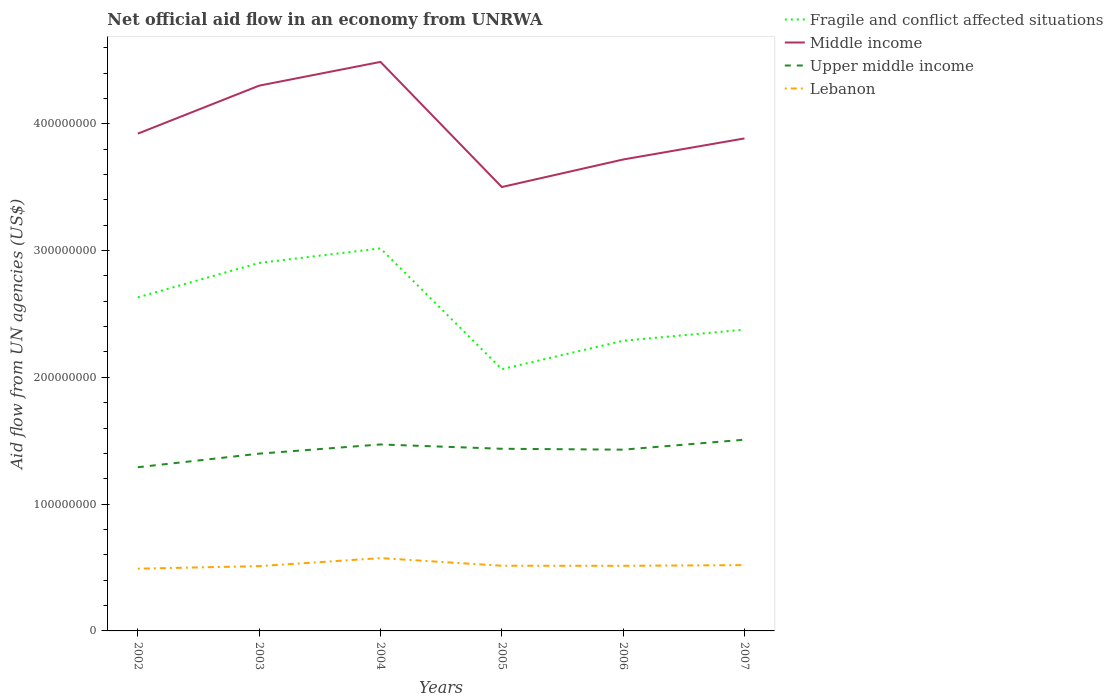Does the line corresponding to Middle income intersect with the line corresponding to Lebanon?
Your response must be concise. No. Across all years, what is the maximum net official aid flow in Fragile and conflict affected situations?
Make the answer very short. 2.06e+08. What is the total net official aid flow in Lebanon in the graph?
Ensure brevity in your answer.  -2.02e+06. What is the difference between the highest and the second highest net official aid flow in Upper middle income?
Your answer should be compact. 2.17e+07. What is the difference between the highest and the lowest net official aid flow in Fragile and conflict affected situations?
Provide a short and direct response. 3. How many lines are there?
Offer a terse response. 4. How many years are there in the graph?
Your answer should be very brief. 6. Are the values on the major ticks of Y-axis written in scientific E-notation?
Make the answer very short. No. How many legend labels are there?
Your response must be concise. 4. How are the legend labels stacked?
Ensure brevity in your answer.  Vertical. What is the title of the graph?
Give a very brief answer. Net official aid flow in an economy from UNRWA. What is the label or title of the X-axis?
Make the answer very short. Years. What is the label or title of the Y-axis?
Offer a terse response. Aid flow from UN agencies (US$). What is the Aid flow from UN agencies (US$) in Fragile and conflict affected situations in 2002?
Keep it short and to the point. 2.63e+08. What is the Aid flow from UN agencies (US$) in Middle income in 2002?
Ensure brevity in your answer.  3.92e+08. What is the Aid flow from UN agencies (US$) of Upper middle income in 2002?
Give a very brief answer. 1.29e+08. What is the Aid flow from UN agencies (US$) in Lebanon in 2002?
Offer a very short reply. 4.91e+07. What is the Aid flow from UN agencies (US$) of Fragile and conflict affected situations in 2003?
Your response must be concise. 2.90e+08. What is the Aid flow from UN agencies (US$) of Middle income in 2003?
Offer a very short reply. 4.30e+08. What is the Aid flow from UN agencies (US$) in Upper middle income in 2003?
Offer a terse response. 1.40e+08. What is the Aid flow from UN agencies (US$) of Lebanon in 2003?
Offer a terse response. 5.11e+07. What is the Aid flow from UN agencies (US$) in Fragile and conflict affected situations in 2004?
Your answer should be very brief. 3.02e+08. What is the Aid flow from UN agencies (US$) in Middle income in 2004?
Make the answer very short. 4.49e+08. What is the Aid flow from UN agencies (US$) of Upper middle income in 2004?
Give a very brief answer. 1.47e+08. What is the Aid flow from UN agencies (US$) of Lebanon in 2004?
Your response must be concise. 5.74e+07. What is the Aid flow from UN agencies (US$) of Fragile and conflict affected situations in 2005?
Provide a short and direct response. 2.06e+08. What is the Aid flow from UN agencies (US$) of Middle income in 2005?
Ensure brevity in your answer.  3.50e+08. What is the Aid flow from UN agencies (US$) of Upper middle income in 2005?
Offer a very short reply. 1.44e+08. What is the Aid flow from UN agencies (US$) of Lebanon in 2005?
Your answer should be compact. 5.14e+07. What is the Aid flow from UN agencies (US$) of Fragile and conflict affected situations in 2006?
Make the answer very short. 2.29e+08. What is the Aid flow from UN agencies (US$) in Middle income in 2006?
Your answer should be compact. 3.72e+08. What is the Aid flow from UN agencies (US$) in Upper middle income in 2006?
Give a very brief answer. 1.43e+08. What is the Aid flow from UN agencies (US$) in Lebanon in 2006?
Give a very brief answer. 5.14e+07. What is the Aid flow from UN agencies (US$) of Fragile and conflict affected situations in 2007?
Keep it short and to the point. 2.38e+08. What is the Aid flow from UN agencies (US$) of Middle income in 2007?
Provide a short and direct response. 3.88e+08. What is the Aid flow from UN agencies (US$) of Upper middle income in 2007?
Give a very brief answer. 1.51e+08. What is the Aid flow from UN agencies (US$) in Lebanon in 2007?
Give a very brief answer. 5.19e+07. Across all years, what is the maximum Aid flow from UN agencies (US$) of Fragile and conflict affected situations?
Give a very brief answer. 3.02e+08. Across all years, what is the maximum Aid flow from UN agencies (US$) of Middle income?
Make the answer very short. 4.49e+08. Across all years, what is the maximum Aid flow from UN agencies (US$) in Upper middle income?
Ensure brevity in your answer.  1.51e+08. Across all years, what is the maximum Aid flow from UN agencies (US$) in Lebanon?
Provide a short and direct response. 5.74e+07. Across all years, what is the minimum Aid flow from UN agencies (US$) in Fragile and conflict affected situations?
Offer a terse response. 2.06e+08. Across all years, what is the minimum Aid flow from UN agencies (US$) of Middle income?
Your answer should be very brief. 3.50e+08. Across all years, what is the minimum Aid flow from UN agencies (US$) of Upper middle income?
Provide a succinct answer. 1.29e+08. Across all years, what is the minimum Aid flow from UN agencies (US$) of Lebanon?
Provide a short and direct response. 4.91e+07. What is the total Aid flow from UN agencies (US$) of Fragile and conflict affected situations in the graph?
Your answer should be compact. 1.53e+09. What is the total Aid flow from UN agencies (US$) in Middle income in the graph?
Ensure brevity in your answer.  2.38e+09. What is the total Aid flow from UN agencies (US$) of Upper middle income in the graph?
Give a very brief answer. 8.53e+08. What is the total Aid flow from UN agencies (US$) in Lebanon in the graph?
Your response must be concise. 3.12e+08. What is the difference between the Aid flow from UN agencies (US$) in Fragile and conflict affected situations in 2002 and that in 2003?
Offer a very short reply. -2.72e+07. What is the difference between the Aid flow from UN agencies (US$) in Middle income in 2002 and that in 2003?
Ensure brevity in your answer.  -3.79e+07. What is the difference between the Aid flow from UN agencies (US$) in Upper middle income in 2002 and that in 2003?
Offer a terse response. -1.07e+07. What is the difference between the Aid flow from UN agencies (US$) in Lebanon in 2002 and that in 2003?
Offer a very short reply. -2.02e+06. What is the difference between the Aid flow from UN agencies (US$) in Fragile and conflict affected situations in 2002 and that in 2004?
Ensure brevity in your answer.  -3.86e+07. What is the difference between the Aid flow from UN agencies (US$) in Middle income in 2002 and that in 2004?
Keep it short and to the point. -5.66e+07. What is the difference between the Aid flow from UN agencies (US$) of Upper middle income in 2002 and that in 2004?
Give a very brief answer. -1.80e+07. What is the difference between the Aid flow from UN agencies (US$) in Lebanon in 2002 and that in 2004?
Provide a short and direct response. -8.34e+06. What is the difference between the Aid flow from UN agencies (US$) in Fragile and conflict affected situations in 2002 and that in 2005?
Offer a terse response. 5.67e+07. What is the difference between the Aid flow from UN agencies (US$) in Middle income in 2002 and that in 2005?
Provide a short and direct response. 4.21e+07. What is the difference between the Aid flow from UN agencies (US$) in Upper middle income in 2002 and that in 2005?
Your answer should be compact. -1.46e+07. What is the difference between the Aid flow from UN agencies (US$) in Lebanon in 2002 and that in 2005?
Ensure brevity in your answer.  -2.33e+06. What is the difference between the Aid flow from UN agencies (US$) in Fragile and conflict affected situations in 2002 and that in 2006?
Your response must be concise. 3.42e+07. What is the difference between the Aid flow from UN agencies (US$) of Middle income in 2002 and that in 2006?
Your response must be concise. 2.04e+07. What is the difference between the Aid flow from UN agencies (US$) in Upper middle income in 2002 and that in 2006?
Make the answer very short. -1.39e+07. What is the difference between the Aid flow from UN agencies (US$) of Lebanon in 2002 and that in 2006?
Keep it short and to the point. -2.27e+06. What is the difference between the Aid flow from UN agencies (US$) of Fragile and conflict affected situations in 2002 and that in 2007?
Your answer should be compact. 2.55e+07. What is the difference between the Aid flow from UN agencies (US$) of Middle income in 2002 and that in 2007?
Provide a succinct answer. 3.76e+06. What is the difference between the Aid flow from UN agencies (US$) of Upper middle income in 2002 and that in 2007?
Provide a succinct answer. -2.17e+07. What is the difference between the Aid flow from UN agencies (US$) of Lebanon in 2002 and that in 2007?
Provide a succinct answer. -2.80e+06. What is the difference between the Aid flow from UN agencies (US$) of Fragile and conflict affected situations in 2003 and that in 2004?
Give a very brief answer. -1.15e+07. What is the difference between the Aid flow from UN agencies (US$) in Middle income in 2003 and that in 2004?
Ensure brevity in your answer.  -1.87e+07. What is the difference between the Aid flow from UN agencies (US$) in Upper middle income in 2003 and that in 2004?
Your response must be concise. -7.26e+06. What is the difference between the Aid flow from UN agencies (US$) in Lebanon in 2003 and that in 2004?
Offer a very short reply. -6.32e+06. What is the difference between the Aid flow from UN agencies (US$) in Fragile and conflict affected situations in 2003 and that in 2005?
Offer a very short reply. 8.38e+07. What is the difference between the Aid flow from UN agencies (US$) in Middle income in 2003 and that in 2005?
Give a very brief answer. 8.00e+07. What is the difference between the Aid flow from UN agencies (US$) in Upper middle income in 2003 and that in 2005?
Ensure brevity in your answer.  -3.86e+06. What is the difference between the Aid flow from UN agencies (US$) in Lebanon in 2003 and that in 2005?
Provide a short and direct response. -3.10e+05. What is the difference between the Aid flow from UN agencies (US$) in Fragile and conflict affected situations in 2003 and that in 2006?
Provide a succinct answer. 6.14e+07. What is the difference between the Aid flow from UN agencies (US$) in Middle income in 2003 and that in 2006?
Keep it short and to the point. 5.82e+07. What is the difference between the Aid flow from UN agencies (US$) in Upper middle income in 2003 and that in 2006?
Your answer should be compact. -3.15e+06. What is the difference between the Aid flow from UN agencies (US$) in Fragile and conflict affected situations in 2003 and that in 2007?
Your answer should be compact. 5.26e+07. What is the difference between the Aid flow from UN agencies (US$) of Middle income in 2003 and that in 2007?
Keep it short and to the point. 4.16e+07. What is the difference between the Aid flow from UN agencies (US$) in Upper middle income in 2003 and that in 2007?
Make the answer very short. -1.10e+07. What is the difference between the Aid flow from UN agencies (US$) in Lebanon in 2003 and that in 2007?
Make the answer very short. -7.80e+05. What is the difference between the Aid flow from UN agencies (US$) of Fragile and conflict affected situations in 2004 and that in 2005?
Make the answer very short. 9.53e+07. What is the difference between the Aid flow from UN agencies (US$) in Middle income in 2004 and that in 2005?
Provide a succinct answer. 9.87e+07. What is the difference between the Aid flow from UN agencies (US$) of Upper middle income in 2004 and that in 2005?
Provide a succinct answer. 3.40e+06. What is the difference between the Aid flow from UN agencies (US$) in Lebanon in 2004 and that in 2005?
Your response must be concise. 6.01e+06. What is the difference between the Aid flow from UN agencies (US$) in Fragile and conflict affected situations in 2004 and that in 2006?
Offer a very short reply. 7.29e+07. What is the difference between the Aid flow from UN agencies (US$) of Middle income in 2004 and that in 2006?
Give a very brief answer. 7.70e+07. What is the difference between the Aid flow from UN agencies (US$) of Upper middle income in 2004 and that in 2006?
Give a very brief answer. 4.11e+06. What is the difference between the Aid flow from UN agencies (US$) of Lebanon in 2004 and that in 2006?
Keep it short and to the point. 6.07e+06. What is the difference between the Aid flow from UN agencies (US$) of Fragile and conflict affected situations in 2004 and that in 2007?
Keep it short and to the point. 6.41e+07. What is the difference between the Aid flow from UN agencies (US$) of Middle income in 2004 and that in 2007?
Provide a succinct answer. 6.03e+07. What is the difference between the Aid flow from UN agencies (US$) of Upper middle income in 2004 and that in 2007?
Your response must be concise. -3.75e+06. What is the difference between the Aid flow from UN agencies (US$) of Lebanon in 2004 and that in 2007?
Ensure brevity in your answer.  5.54e+06. What is the difference between the Aid flow from UN agencies (US$) in Fragile and conflict affected situations in 2005 and that in 2006?
Keep it short and to the point. -2.24e+07. What is the difference between the Aid flow from UN agencies (US$) in Middle income in 2005 and that in 2006?
Offer a very short reply. -2.17e+07. What is the difference between the Aid flow from UN agencies (US$) of Upper middle income in 2005 and that in 2006?
Your answer should be very brief. 7.10e+05. What is the difference between the Aid flow from UN agencies (US$) of Fragile and conflict affected situations in 2005 and that in 2007?
Provide a succinct answer. -3.12e+07. What is the difference between the Aid flow from UN agencies (US$) of Middle income in 2005 and that in 2007?
Offer a very short reply. -3.83e+07. What is the difference between the Aid flow from UN agencies (US$) of Upper middle income in 2005 and that in 2007?
Offer a terse response. -7.15e+06. What is the difference between the Aid flow from UN agencies (US$) in Lebanon in 2005 and that in 2007?
Your response must be concise. -4.70e+05. What is the difference between the Aid flow from UN agencies (US$) of Fragile and conflict affected situations in 2006 and that in 2007?
Offer a terse response. -8.77e+06. What is the difference between the Aid flow from UN agencies (US$) of Middle income in 2006 and that in 2007?
Your answer should be very brief. -1.66e+07. What is the difference between the Aid flow from UN agencies (US$) of Upper middle income in 2006 and that in 2007?
Provide a succinct answer. -7.86e+06. What is the difference between the Aid flow from UN agencies (US$) in Lebanon in 2006 and that in 2007?
Your answer should be compact. -5.30e+05. What is the difference between the Aid flow from UN agencies (US$) of Fragile and conflict affected situations in 2002 and the Aid flow from UN agencies (US$) of Middle income in 2003?
Give a very brief answer. -1.67e+08. What is the difference between the Aid flow from UN agencies (US$) in Fragile and conflict affected situations in 2002 and the Aid flow from UN agencies (US$) in Upper middle income in 2003?
Provide a short and direct response. 1.23e+08. What is the difference between the Aid flow from UN agencies (US$) of Fragile and conflict affected situations in 2002 and the Aid flow from UN agencies (US$) of Lebanon in 2003?
Your answer should be very brief. 2.12e+08. What is the difference between the Aid flow from UN agencies (US$) of Middle income in 2002 and the Aid flow from UN agencies (US$) of Upper middle income in 2003?
Your answer should be compact. 2.52e+08. What is the difference between the Aid flow from UN agencies (US$) of Middle income in 2002 and the Aid flow from UN agencies (US$) of Lebanon in 2003?
Ensure brevity in your answer.  3.41e+08. What is the difference between the Aid flow from UN agencies (US$) in Upper middle income in 2002 and the Aid flow from UN agencies (US$) in Lebanon in 2003?
Your answer should be compact. 7.80e+07. What is the difference between the Aid flow from UN agencies (US$) of Fragile and conflict affected situations in 2002 and the Aid flow from UN agencies (US$) of Middle income in 2004?
Offer a terse response. -1.86e+08. What is the difference between the Aid flow from UN agencies (US$) of Fragile and conflict affected situations in 2002 and the Aid flow from UN agencies (US$) of Upper middle income in 2004?
Your answer should be very brief. 1.16e+08. What is the difference between the Aid flow from UN agencies (US$) of Fragile and conflict affected situations in 2002 and the Aid flow from UN agencies (US$) of Lebanon in 2004?
Your answer should be compact. 2.06e+08. What is the difference between the Aid flow from UN agencies (US$) of Middle income in 2002 and the Aid flow from UN agencies (US$) of Upper middle income in 2004?
Keep it short and to the point. 2.45e+08. What is the difference between the Aid flow from UN agencies (US$) of Middle income in 2002 and the Aid flow from UN agencies (US$) of Lebanon in 2004?
Give a very brief answer. 3.35e+08. What is the difference between the Aid flow from UN agencies (US$) of Upper middle income in 2002 and the Aid flow from UN agencies (US$) of Lebanon in 2004?
Your answer should be compact. 7.17e+07. What is the difference between the Aid flow from UN agencies (US$) in Fragile and conflict affected situations in 2002 and the Aid flow from UN agencies (US$) in Middle income in 2005?
Give a very brief answer. -8.70e+07. What is the difference between the Aid flow from UN agencies (US$) of Fragile and conflict affected situations in 2002 and the Aid flow from UN agencies (US$) of Upper middle income in 2005?
Make the answer very short. 1.19e+08. What is the difference between the Aid flow from UN agencies (US$) in Fragile and conflict affected situations in 2002 and the Aid flow from UN agencies (US$) in Lebanon in 2005?
Ensure brevity in your answer.  2.12e+08. What is the difference between the Aid flow from UN agencies (US$) in Middle income in 2002 and the Aid flow from UN agencies (US$) in Upper middle income in 2005?
Make the answer very short. 2.49e+08. What is the difference between the Aid flow from UN agencies (US$) in Middle income in 2002 and the Aid flow from UN agencies (US$) in Lebanon in 2005?
Offer a very short reply. 3.41e+08. What is the difference between the Aid flow from UN agencies (US$) in Upper middle income in 2002 and the Aid flow from UN agencies (US$) in Lebanon in 2005?
Your answer should be compact. 7.77e+07. What is the difference between the Aid flow from UN agencies (US$) of Fragile and conflict affected situations in 2002 and the Aid flow from UN agencies (US$) of Middle income in 2006?
Your response must be concise. -1.09e+08. What is the difference between the Aid flow from UN agencies (US$) in Fragile and conflict affected situations in 2002 and the Aid flow from UN agencies (US$) in Upper middle income in 2006?
Offer a terse response. 1.20e+08. What is the difference between the Aid flow from UN agencies (US$) in Fragile and conflict affected situations in 2002 and the Aid flow from UN agencies (US$) in Lebanon in 2006?
Provide a succinct answer. 2.12e+08. What is the difference between the Aid flow from UN agencies (US$) in Middle income in 2002 and the Aid flow from UN agencies (US$) in Upper middle income in 2006?
Your response must be concise. 2.49e+08. What is the difference between the Aid flow from UN agencies (US$) in Middle income in 2002 and the Aid flow from UN agencies (US$) in Lebanon in 2006?
Make the answer very short. 3.41e+08. What is the difference between the Aid flow from UN agencies (US$) in Upper middle income in 2002 and the Aid flow from UN agencies (US$) in Lebanon in 2006?
Provide a short and direct response. 7.77e+07. What is the difference between the Aid flow from UN agencies (US$) of Fragile and conflict affected situations in 2002 and the Aid flow from UN agencies (US$) of Middle income in 2007?
Your answer should be very brief. -1.25e+08. What is the difference between the Aid flow from UN agencies (US$) of Fragile and conflict affected situations in 2002 and the Aid flow from UN agencies (US$) of Upper middle income in 2007?
Provide a short and direct response. 1.12e+08. What is the difference between the Aid flow from UN agencies (US$) in Fragile and conflict affected situations in 2002 and the Aid flow from UN agencies (US$) in Lebanon in 2007?
Your answer should be compact. 2.11e+08. What is the difference between the Aid flow from UN agencies (US$) of Middle income in 2002 and the Aid flow from UN agencies (US$) of Upper middle income in 2007?
Provide a short and direct response. 2.41e+08. What is the difference between the Aid flow from UN agencies (US$) of Middle income in 2002 and the Aid flow from UN agencies (US$) of Lebanon in 2007?
Provide a succinct answer. 3.40e+08. What is the difference between the Aid flow from UN agencies (US$) in Upper middle income in 2002 and the Aid flow from UN agencies (US$) in Lebanon in 2007?
Offer a very short reply. 7.72e+07. What is the difference between the Aid flow from UN agencies (US$) in Fragile and conflict affected situations in 2003 and the Aid flow from UN agencies (US$) in Middle income in 2004?
Offer a terse response. -1.59e+08. What is the difference between the Aid flow from UN agencies (US$) in Fragile and conflict affected situations in 2003 and the Aid flow from UN agencies (US$) in Upper middle income in 2004?
Provide a short and direct response. 1.43e+08. What is the difference between the Aid flow from UN agencies (US$) in Fragile and conflict affected situations in 2003 and the Aid flow from UN agencies (US$) in Lebanon in 2004?
Provide a succinct answer. 2.33e+08. What is the difference between the Aid flow from UN agencies (US$) of Middle income in 2003 and the Aid flow from UN agencies (US$) of Upper middle income in 2004?
Ensure brevity in your answer.  2.83e+08. What is the difference between the Aid flow from UN agencies (US$) of Middle income in 2003 and the Aid flow from UN agencies (US$) of Lebanon in 2004?
Ensure brevity in your answer.  3.73e+08. What is the difference between the Aid flow from UN agencies (US$) of Upper middle income in 2003 and the Aid flow from UN agencies (US$) of Lebanon in 2004?
Make the answer very short. 8.24e+07. What is the difference between the Aid flow from UN agencies (US$) of Fragile and conflict affected situations in 2003 and the Aid flow from UN agencies (US$) of Middle income in 2005?
Give a very brief answer. -5.99e+07. What is the difference between the Aid flow from UN agencies (US$) in Fragile and conflict affected situations in 2003 and the Aid flow from UN agencies (US$) in Upper middle income in 2005?
Keep it short and to the point. 1.47e+08. What is the difference between the Aid flow from UN agencies (US$) in Fragile and conflict affected situations in 2003 and the Aid flow from UN agencies (US$) in Lebanon in 2005?
Make the answer very short. 2.39e+08. What is the difference between the Aid flow from UN agencies (US$) of Middle income in 2003 and the Aid flow from UN agencies (US$) of Upper middle income in 2005?
Ensure brevity in your answer.  2.86e+08. What is the difference between the Aid flow from UN agencies (US$) of Middle income in 2003 and the Aid flow from UN agencies (US$) of Lebanon in 2005?
Provide a short and direct response. 3.79e+08. What is the difference between the Aid flow from UN agencies (US$) in Upper middle income in 2003 and the Aid flow from UN agencies (US$) in Lebanon in 2005?
Your answer should be compact. 8.84e+07. What is the difference between the Aid flow from UN agencies (US$) in Fragile and conflict affected situations in 2003 and the Aid flow from UN agencies (US$) in Middle income in 2006?
Give a very brief answer. -8.16e+07. What is the difference between the Aid flow from UN agencies (US$) of Fragile and conflict affected situations in 2003 and the Aid flow from UN agencies (US$) of Upper middle income in 2006?
Provide a short and direct response. 1.47e+08. What is the difference between the Aid flow from UN agencies (US$) in Fragile and conflict affected situations in 2003 and the Aid flow from UN agencies (US$) in Lebanon in 2006?
Your answer should be compact. 2.39e+08. What is the difference between the Aid flow from UN agencies (US$) in Middle income in 2003 and the Aid flow from UN agencies (US$) in Upper middle income in 2006?
Offer a very short reply. 2.87e+08. What is the difference between the Aid flow from UN agencies (US$) of Middle income in 2003 and the Aid flow from UN agencies (US$) of Lebanon in 2006?
Ensure brevity in your answer.  3.79e+08. What is the difference between the Aid flow from UN agencies (US$) in Upper middle income in 2003 and the Aid flow from UN agencies (US$) in Lebanon in 2006?
Your answer should be very brief. 8.84e+07. What is the difference between the Aid flow from UN agencies (US$) in Fragile and conflict affected situations in 2003 and the Aid flow from UN agencies (US$) in Middle income in 2007?
Give a very brief answer. -9.82e+07. What is the difference between the Aid flow from UN agencies (US$) in Fragile and conflict affected situations in 2003 and the Aid flow from UN agencies (US$) in Upper middle income in 2007?
Keep it short and to the point. 1.39e+08. What is the difference between the Aid flow from UN agencies (US$) in Fragile and conflict affected situations in 2003 and the Aid flow from UN agencies (US$) in Lebanon in 2007?
Make the answer very short. 2.38e+08. What is the difference between the Aid flow from UN agencies (US$) in Middle income in 2003 and the Aid flow from UN agencies (US$) in Upper middle income in 2007?
Your response must be concise. 2.79e+08. What is the difference between the Aid flow from UN agencies (US$) in Middle income in 2003 and the Aid flow from UN agencies (US$) in Lebanon in 2007?
Provide a succinct answer. 3.78e+08. What is the difference between the Aid flow from UN agencies (US$) of Upper middle income in 2003 and the Aid flow from UN agencies (US$) of Lebanon in 2007?
Provide a short and direct response. 8.79e+07. What is the difference between the Aid flow from UN agencies (US$) in Fragile and conflict affected situations in 2004 and the Aid flow from UN agencies (US$) in Middle income in 2005?
Keep it short and to the point. -4.84e+07. What is the difference between the Aid flow from UN agencies (US$) of Fragile and conflict affected situations in 2004 and the Aid flow from UN agencies (US$) of Upper middle income in 2005?
Your answer should be compact. 1.58e+08. What is the difference between the Aid flow from UN agencies (US$) in Fragile and conflict affected situations in 2004 and the Aid flow from UN agencies (US$) in Lebanon in 2005?
Give a very brief answer. 2.50e+08. What is the difference between the Aid flow from UN agencies (US$) of Middle income in 2004 and the Aid flow from UN agencies (US$) of Upper middle income in 2005?
Your answer should be very brief. 3.05e+08. What is the difference between the Aid flow from UN agencies (US$) of Middle income in 2004 and the Aid flow from UN agencies (US$) of Lebanon in 2005?
Your answer should be very brief. 3.97e+08. What is the difference between the Aid flow from UN agencies (US$) in Upper middle income in 2004 and the Aid flow from UN agencies (US$) in Lebanon in 2005?
Provide a succinct answer. 9.56e+07. What is the difference between the Aid flow from UN agencies (US$) of Fragile and conflict affected situations in 2004 and the Aid flow from UN agencies (US$) of Middle income in 2006?
Provide a short and direct response. -7.01e+07. What is the difference between the Aid flow from UN agencies (US$) of Fragile and conflict affected situations in 2004 and the Aid flow from UN agencies (US$) of Upper middle income in 2006?
Give a very brief answer. 1.59e+08. What is the difference between the Aid flow from UN agencies (US$) in Fragile and conflict affected situations in 2004 and the Aid flow from UN agencies (US$) in Lebanon in 2006?
Offer a terse response. 2.50e+08. What is the difference between the Aid flow from UN agencies (US$) in Middle income in 2004 and the Aid flow from UN agencies (US$) in Upper middle income in 2006?
Ensure brevity in your answer.  3.06e+08. What is the difference between the Aid flow from UN agencies (US$) of Middle income in 2004 and the Aid flow from UN agencies (US$) of Lebanon in 2006?
Keep it short and to the point. 3.97e+08. What is the difference between the Aid flow from UN agencies (US$) in Upper middle income in 2004 and the Aid flow from UN agencies (US$) in Lebanon in 2006?
Provide a short and direct response. 9.57e+07. What is the difference between the Aid flow from UN agencies (US$) in Fragile and conflict affected situations in 2004 and the Aid flow from UN agencies (US$) in Middle income in 2007?
Your answer should be compact. -8.67e+07. What is the difference between the Aid flow from UN agencies (US$) in Fragile and conflict affected situations in 2004 and the Aid flow from UN agencies (US$) in Upper middle income in 2007?
Your response must be concise. 1.51e+08. What is the difference between the Aid flow from UN agencies (US$) of Fragile and conflict affected situations in 2004 and the Aid flow from UN agencies (US$) of Lebanon in 2007?
Your response must be concise. 2.50e+08. What is the difference between the Aid flow from UN agencies (US$) in Middle income in 2004 and the Aid flow from UN agencies (US$) in Upper middle income in 2007?
Ensure brevity in your answer.  2.98e+08. What is the difference between the Aid flow from UN agencies (US$) of Middle income in 2004 and the Aid flow from UN agencies (US$) of Lebanon in 2007?
Give a very brief answer. 3.97e+08. What is the difference between the Aid flow from UN agencies (US$) of Upper middle income in 2004 and the Aid flow from UN agencies (US$) of Lebanon in 2007?
Your answer should be compact. 9.52e+07. What is the difference between the Aid flow from UN agencies (US$) of Fragile and conflict affected situations in 2005 and the Aid flow from UN agencies (US$) of Middle income in 2006?
Provide a short and direct response. -1.65e+08. What is the difference between the Aid flow from UN agencies (US$) in Fragile and conflict affected situations in 2005 and the Aid flow from UN agencies (US$) in Upper middle income in 2006?
Provide a succinct answer. 6.35e+07. What is the difference between the Aid flow from UN agencies (US$) in Fragile and conflict affected situations in 2005 and the Aid flow from UN agencies (US$) in Lebanon in 2006?
Your answer should be very brief. 1.55e+08. What is the difference between the Aid flow from UN agencies (US$) of Middle income in 2005 and the Aid flow from UN agencies (US$) of Upper middle income in 2006?
Give a very brief answer. 2.07e+08. What is the difference between the Aid flow from UN agencies (US$) in Middle income in 2005 and the Aid flow from UN agencies (US$) in Lebanon in 2006?
Provide a succinct answer. 2.99e+08. What is the difference between the Aid flow from UN agencies (US$) in Upper middle income in 2005 and the Aid flow from UN agencies (US$) in Lebanon in 2006?
Make the answer very short. 9.23e+07. What is the difference between the Aid flow from UN agencies (US$) in Fragile and conflict affected situations in 2005 and the Aid flow from UN agencies (US$) in Middle income in 2007?
Your answer should be very brief. -1.82e+08. What is the difference between the Aid flow from UN agencies (US$) of Fragile and conflict affected situations in 2005 and the Aid flow from UN agencies (US$) of Upper middle income in 2007?
Offer a very short reply. 5.56e+07. What is the difference between the Aid flow from UN agencies (US$) of Fragile and conflict affected situations in 2005 and the Aid flow from UN agencies (US$) of Lebanon in 2007?
Offer a terse response. 1.55e+08. What is the difference between the Aid flow from UN agencies (US$) of Middle income in 2005 and the Aid flow from UN agencies (US$) of Upper middle income in 2007?
Give a very brief answer. 1.99e+08. What is the difference between the Aid flow from UN agencies (US$) in Middle income in 2005 and the Aid flow from UN agencies (US$) in Lebanon in 2007?
Give a very brief answer. 2.98e+08. What is the difference between the Aid flow from UN agencies (US$) of Upper middle income in 2005 and the Aid flow from UN agencies (US$) of Lebanon in 2007?
Your answer should be compact. 9.18e+07. What is the difference between the Aid flow from UN agencies (US$) of Fragile and conflict affected situations in 2006 and the Aid flow from UN agencies (US$) of Middle income in 2007?
Your answer should be compact. -1.60e+08. What is the difference between the Aid flow from UN agencies (US$) in Fragile and conflict affected situations in 2006 and the Aid flow from UN agencies (US$) in Upper middle income in 2007?
Provide a short and direct response. 7.80e+07. What is the difference between the Aid flow from UN agencies (US$) in Fragile and conflict affected situations in 2006 and the Aid flow from UN agencies (US$) in Lebanon in 2007?
Offer a terse response. 1.77e+08. What is the difference between the Aid flow from UN agencies (US$) in Middle income in 2006 and the Aid flow from UN agencies (US$) in Upper middle income in 2007?
Ensure brevity in your answer.  2.21e+08. What is the difference between the Aid flow from UN agencies (US$) of Middle income in 2006 and the Aid flow from UN agencies (US$) of Lebanon in 2007?
Provide a succinct answer. 3.20e+08. What is the difference between the Aid flow from UN agencies (US$) of Upper middle income in 2006 and the Aid flow from UN agencies (US$) of Lebanon in 2007?
Ensure brevity in your answer.  9.11e+07. What is the average Aid flow from UN agencies (US$) in Fragile and conflict affected situations per year?
Your response must be concise. 2.55e+08. What is the average Aid flow from UN agencies (US$) of Middle income per year?
Keep it short and to the point. 3.97e+08. What is the average Aid flow from UN agencies (US$) of Upper middle income per year?
Offer a very short reply. 1.42e+08. What is the average Aid flow from UN agencies (US$) of Lebanon per year?
Your response must be concise. 5.20e+07. In the year 2002, what is the difference between the Aid flow from UN agencies (US$) of Fragile and conflict affected situations and Aid flow from UN agencies (US$) of Middle income?
Your answer should be compact. -1.29e+08. In the year 2002, what is the difference between the Aid flow from UN agencies (US$) of Fragile and conflict affected situations and Aid flow from UN agencies (US$) of Upper middle income?
Keep it short and to the point. 1.34e+08. In the year 2002, what is the difference between the Aid flow from UN agencies (US$) of Fragile and conflict affected situations and Aid flow from UN agencies (US$) of Lebanon?
Provide a short and direct response. 2.14e+08. In the year 2002, what is the difference between the Aid flow from UN agencies (US$) in Middle income and Aid flow from UN agencies (US$) in Upper middle income?
Offer a terse response. 2.63e+08. In the year 2002, what is the difference between the Aid flow from UN agencies (US$) in Middle income and Aid flow from UN agencies (US$) in Lebanon?
Your response must be concise. 3.43e+08. In the year 2002, what is the difference between the Aid flow from UN agencies (US$) of Upper middle income and Aid flow from UN agencies (US$) of Lebanon?
Provide a short and direct response. 8.00e+07. In the year 2003, what is the difference between the Aid flow from UN agencies (US$) in Fragile and conflict affected situations and Aid flow from UN agencies (US$) in Middle income?
Offer a very short reply. -1.40e+08. In the year 2003, what is the difference between the Aid flow from UN agencies (US$) in Fragile and conflict affected situations and Aid flow from UN agencies (US$) in Upper middle income?
Offer a terse response. 1.50e+08. In the year 2003, what is the difference between the Aid flow from UN agencies (US$) of Fragile and conflict affected situations and Aid flow from UN agencies (US$) of Lebanon?
Offer a very short reply. 2.39e+08. In the year 2003, what is the difference between the Aid flow from UN agencies (US$) of Middle income and Aid flow from UN agencies (US$) of Upper middle income?
Offer a terse response. 2.90e+08. In the year 2003, what is the difference between the Aid flow from UN agencies (US$) of Middle income and Aid flow from UN agencies (US$) of Lebanon?
Offer a terse response. 3.79e+08. In the year 2003, what is the difference between the Aid flow from UN agencies (US$) of Upper middle income and Aid flow from UN agencies (US$) of Lebanon?
Your answer should be very brief. 8.87e+07. In the year 2004, what is the difference between the Aid flow from UN agencies (US$) of Fragile and conflict affected situations and Aid flow from UN agencies (US$) of Middle income?
Provide a succinct answer. -1.47e+08. In the year 2004, what is the difference between the Aid flow from UN agencies (US$) in Fragile and conflict affected situations and Aid flow from UN agencies (US$) in Upper middle income?
Give a very brief answer. 1.55e+08. In the year 2004, what is the difference between the Aid flow from UN agencies (US$) of Fragile and conflict affected situations and Aid flow from UN agencies (US$) of Lebanon?
Provide a succinct answer. 2.44e+08. In the year 2004, what is the difference between the Aid flow from UN agencies (US$) in Middle income and Aid flow from UN agencies (US$) in Upper middle income?
Make the answer very short. 3.02e+08. In the year 2004, what is the difference between the Aid flow from UN agencies (US$) of Middle income and Aid flow from UN agencies (US$) of Lebanon?
Keep it short and to the point. 3.91e+08. In the year 2004, what is the difference between the Aid flow from UN agencies (US$) in Upper middle income and Aid flow from UN agencies (US$) in Lebanon?
Give a very brief answer. 8.96e+07. In the year 2005, what is the difference between the Aid flow from UN agencies (US$) in Fragile and conflict affected situations and Aid flow from UN agencies (US$) in Middle income?
Give a very brief answer. -1.44e+08. In the year 2005, what is the difference between the Aid flow from UN agencies (US$) in Fragile and conflict affected situations and Aid flow from UN agencies (US$) in Upper middle income?
Your response must be concise. 6.28e+07. In the year 2005, what is the difference between the Aid flow from UN agencies (US$) of Fragile and conflict affected situations and Aid flow from UN agencies (US$) of Lebanon?
Your answer should be compact. 1.55e+08. In the year 2005, what is the difference between the Aid flow from UN agencies (US$) of Middle income and Aid flow from UN agencies (US$) of Upper middle income?
Provide a succinct answer. 2.06e+08. In the year 2005, what is the difference between the Aid flow from UN agencies (US$) in Middle income and Aid flow from UN agencies (US$) in Lebanon?
Your response must be concise. 2.99e+08. In the year 2005, what is the difference between the Aid flow from UN agencies (US$) of Upper middle income and Aid flow from UN agencies (US$) of Lebanon?
Keep it short and to the point. 9.22e+07. In the year 2006, what is the difference between the Aid flow from UN agencies (US$) of Fragile and conflict affected situations and Aid flow from UN agencies (US$) of Middle income?
Ensure brevity in your answer.  -1.43e+08. In the year 2006, what is the difference between the Aid flow from UN agencies (US$) in Fragile and conflict affected situations and Aid flow from UN agencies (US$) in Upper middle income?
Offer a very short reply. 8.59e+07. In the year 2006, what is the difference between the Aid flow from UN agencies (US$) of Fragile and conflict affected situations and Aid flow from UN agencies (US$) of Lebanon?
Offer a very short reply. 1.77e+08. In the year 2006, what is the difference between the Aid flow from UN agencies (US$) of Middle income and Aid flow from UN agencies (US$) of Upper middle income?
Make the answer very short. 2.29e+08. In the year 2006, what is the difference between the Aid flow from UN agencies (US$) in Middle income and Aid flow from UN agencies (US$) in Lebanon?
Your response must be concise. 3.20e+08. In the year 2006, what is the difference between the Aid flow from UN agencies (US$) of Upper middle income and Aid flow from UN agencies (US$) of Lebanon?
Your answer should be very brief. 9.16e+07. In the year 2007, what is the difference between the Aid flow from UN agencies (US$) of Fragile and conflict affected situations and Aid flow from UN agencies (US$) of Middle income?
Your answer should be compact. -1.51e+08. In the year 2007, what is the difference between the Aid flow from UN agencies (US$) of Fragile and conflict affected situations and Aid flow from UN agencies (US$) of Upper middle income?
Provide a short and direct response. 8.68e+07. In the year 2007, what is the difference between the Aid flow from UN agencies (US$) in Fragile and conflict affected situations and Aid flow from UN agencies (US$) in Lebanon?
Your answer should be compact. 1.86e+08. In the year 2007, what is the difference between the Aid flow from UN agencies (US$) in Middle income and Aid flow from UN agencies (US$) in Upper middle income?
Keep it short and to the point. 2.38e+08. In the year 2007, what is the difference between the Aid flow from UN agencies (US$) in Middle income and Aid flow from UN agencies (US$) in Lebanon?
Provide a succinct answer. 3.37e+08. In the year 2007, what is the difference between the Aid flow from UN agencies (US$) in Upper middle income and Aid flow from UN agencies (US$) in Lebanon?
Provide a short and direct response. 9.89e+07. What is the ratio of the Aid flow from UN agencies (US$) of Fragile and conflict affected situations in 2002 to that in 2003?
Offer a very short reply. 0.91. What is the ratio of the Aid flow from UN agencies (US$) in Middle income in 2002 to that in 2003?
Your answer should be very brief. 0.91. What is the ratio of the Aid flow from UN agencies (US$) of Upper middle income in 2002 to that in 2003?
Ensure brevity in your answer.  0.92. What is the ratio of the Aid flow from UN agencies (US$) in Lebanon in 2002 to that in 2003?
Offer a terse response. 0.96. What is the ratio of the Aid flow from UN agencies (US$) of Fragile and conflict affected situations in 2002 to that in 2004?
Offer a terse response. 0.87. What is the ratio of the Aid flow from UN agencies (US$) in Middle income in 2002 to that in 2004?
Give a very brief answer. 0.87. What is the ratio of the Aid flow from UN agencies (US$) of Upper middle income in 2002 to that in 2004?
Ensure brevity in your answer.  0.88. What is the ratio of the Aid flow from UN agencies (US$) in Lebanon in 2002 to that in 2004?
Your response must be concise. 0.85. What is the ratio of the Aid flow from UN agencies (US$) of Fragile and conflict affected situations in 2002 to that in 2005?
Make the answer very short. 1.27. What is the ratio of the Aid flow from UN agencies (US$) in Middle income in 2002 to that in 2005?
Your response must be concise. 1.12. What is the ratio of the Aid flow from UN agencies (US$) of Upper middle income in 2002 to that in 2005?
Ensure brevity in your answer.  0.9. What is the ratio of the Aid flow from UN agencies (US$) in Lebanon in 2002 to that in 2005?
Offer a terse response. 0.95. What is the ratio of the Aid flow from UN agencies (US$) of Fragile and conflict affected situations in 2002 to that in 2006?
Offer a very short reply. 1.15. What is the ratio of the Aid flow from UN agencies (US$) in Middle income in 2002 to that in 2006?
Keep it short and to the point. 1.05. What is the ratio of the Aid flow from UN agencies (US$) in Upper middle income in 2002 to that in 2006?
Your response must be concise. 0.9. What is the ratio of the Aid flow from UN agencies (US$) in Lebanon in 2002 to that in 2006?
Your response must be concise. 0.96. What is the ratio of the Aid flow from UN agencies (US$) of Fragile and conflict affected situations in 2002 to that in 2007?
Provide a succinct answer. 1.11. What is the ratio of the Aid flow from UN agencies (US$) in Middle income in 2002 to that in 2007?
Provide a short and direct response. 1.01. What is the ratio of the Aid flow from UN agencies (US$) of Upper middle income in 2002 to that in 2007?
Provide a succinct answer. 0.86. What is the ratio of the Aid flow from UN agencies (US$) of Lebanon in 2002 to that in 2007?
Your response must be concise. 0.95. What is the ratio of the Aid flow from UN agencies (US$) of Middle income in 2003 to that in 2004?
Ensure brevity in your answer.  0.96. What is the ratio of the Aid flow from UN agencies (US$) of Upper middle income in 2003 to that in 2004?
Offer a very short reply. 0.95. What is the ratio of the Aid flow from UN agencies (US$) in Lebanon in 2003 to that in 2004?
Your answer should be compact. 0.89. What is the ratio of the Aid flow from UN agencies (US$) in Fragile and conflict affected situations in 2003 to that in 2005?
Your answer should be very brief. 1.41. What is the ratio of the Aid flow from UN agencies (US$) in Middle income in 2003 to that in 2005?
Your response must be concise. 1.23. What is the ratio of the Aid flow from UN agencies (US$) in Upper middle income in 2003 to that in 2005?
Your answer should be compact. 0.97. What is the ratio of the Aid flow from UN agencies (US$) of Lebanon in 2003 to that in 2005?
Provide a succinct answer. 0.99. What is the ratio of the Aid flow from UN agencies (US$) of Fragile and conflict affected situations in 2003 to that in 2006?
Ensure brevity in your answer.  1.27. What is the ratio of the Aid flow from UN agencies (US$) in Middle income in 2003 to that in 2006?
Keep it short and to the point. 1.16. What is the ratio of the Aid flow from UN agencies (US$) of Fragile and conflict affected situations in 2003 to that in 2007?
Your answer should be compact. 1.22. What is the ratio of the Aid flow from UN agencies (US$) of Middle income in 2003 to that in 2007?
Ensure brevity in your answer.  1.11. What is the ratio of the Aid flow from UN agencies (US$) of Upper middle income in 2003 to that in 2007?
Ensure brevity in your answer.  0.93. What is the ratio of the Aid flow from UN agencies (US$) in Lebanon in 2003 to that in 2007?
Your answer should be very brief. 0.98. What is the ratio of the Aid flow from UN agencies (US$) of Fragile and conflict affected situations in 2004 to that in 2005?
Make the answer very short. 1.46. What is the ratio of the Aid flow from UN agencies (US$) of Middle income in 2004 to that in 2005?
Your answer should be very brief. 1.28. What is the ratio of the Aid flow from UN agencies (US$) in Upper middle income in 2004 to that in 2005?
Your answer should be very brief. 1.02. What is the ratio of the Aid flow from UN agencies (US$) of Lebanon in 2004 to that in 2005?
Give a very brief answer. 1.12. What is the ratio of the Aid flow from UN agencies (US$) of Fragile and conflict affected situations in 2004 to that in 2006?
Ensure brevity in your answer.  1.32. What is the ratio of the Aid flow from UN agencies (US$) in Middle income in 2004 to that in 2006?
Your response must be concise. 1.21. What is the ratio of the Aid flow from UN agencies (US$) in Upper middle income in 2004 to that in 2006?
Your answer should be compact. 1.03. What is the ratio of the Aid flow from UN agencies (US$) in Lebanon in 2004 to that in 2006?
Your answer should be very brief. 1.12. What is the ratio of the Aid flow from UN agencies (US$) in Fragile and conflict affected situations in 2004 to that in 2007?
Your answer should be very brief. 1.27. What is the ratio of the Aid flow from UN agencies (US$) of Middle income in 2004 to that in 2007?
Keep it short and to the point. 1.16. What is the ratio of the Aid flow from UN agencies (US$) in Upper middle income in 2004 to that in 2007?
Offer a terse response. 0.98. What is the ratio of the Aid flow from UN agencies (US$) of Lebanon in 2004 to that in 2007?
Your response must be concise. 1.11. What is the ratio of the Aid flow from UN agencies (US$) in Fragile and conflict affected situations in 2005 to that in 2006?
Your answer should be very brief. 0.9. What is the ratio of the Aid flow from UN agencies (US$) of Middle income in 2005 to that in 2006?
Your answer should be very brief. 0.94. What is the ratio of the Aid flow from UN agencies (US$) of Upper middle income in 2005 to that in 2006?
Give a very brief answer. 1. What is the ratio of the Aid flow from UN agencies (US$) of Fragile and conflict affected situations in 2005 to that in 2007?
Make the answer very short. 0.87. What is the ratio of the Aid flow from UN agencies (US$) in Middle income in 2005 to that in 2007?
Your response must be concise. 0.9. What is the ratio of the Aid flow from UN agencies (US$) of Upper middle income in 2005 to that in 2007?
Provide a succinct answer. 0.95. What is the ratio of the Aid flow from UN agencies (US$) of Lebanon in 2005 to that in 2007?
Make the answer very short. 0.99. What is the ratio of the Aid flow from UN agencies (US$) in Fragile and conflict affected situations in 2006 to that in 2007?
Your answer should be compact. 0.96. What is the ratio of the Aid flow from UN agencies (US$) in Middle income in 2006 to that in 2007?
Keep it short and to the point. 0.96. What is the ratio of the Aid flow from UN agencies (US$) of Upper middle income in 2006 to that in 2007?
Your response must be concise. 0.95. What is the difference between the highest and the second highest Aid flow from UN agencies (US$) of Fragile and conflict affected situations?
Your answer should be very brief. 1.15e+07. What is the difference between the highest and the second highest Aid flow from UN agencies (US$) of Middle income?
Offer a very short reply. 1.87e+07. What is the difference between the highest and the second highest Aid flow from UN agencies (US$) in Upper middle income?
Offer a terse response. 3.75e+06. What is the difference between the highest and the second highest Aid flow from UN agencies (US$) in Lebanon?
Your response must be concise. 5.54e+06. What is the difference between the highest and the lowest Aid flow from UN agencies (US$) of Fragile and conflict affected situations?
Your response must be concise. 9.53e+07. What is the difference between the highest and the lowest Aid flow from UN agencies (US$) of Middle income?
Provide a succinct answer. 9.87e+07. What is the difference between the highest and the lowest Aid flow from UN agencies (US$) in Upper middle income?
Make the answer very short. 2.17e+07. What is the difference between the highest and the lowest Aid flow from UN agencies (US$) of Lebanon?
Offer a terse response. 8.34e+06. 